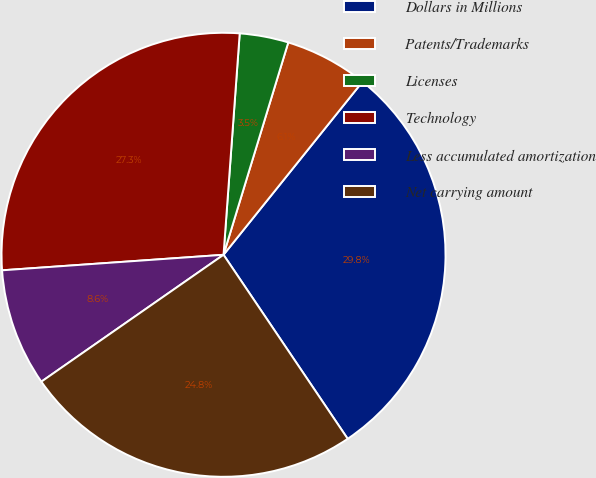Convert chart to OTSL. <chart><loc_0><loc_0><loc_500><loc_500><pie_chart><fcel>Dollars in Millions<fcel>Patents/Trademarks<fcel>Licenses<fcel>Technology<fcel>Less accumulated amortization<fcel>Net carrying amount<nl><fcel>29.79%<fcel>6.06%<fcel>3.55%<fcel>27.28%<fcel>8.57%<fcel>24.77%<nl></chart> 